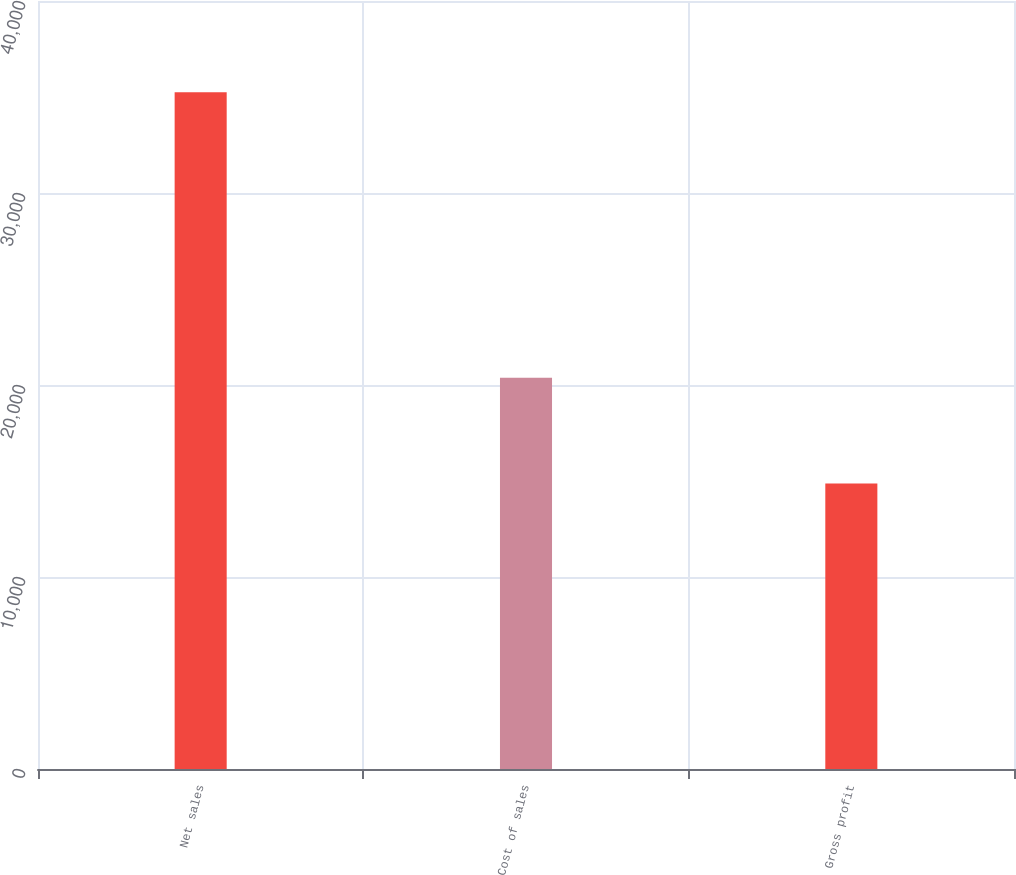Convert chart to OTSL. <chart><loc_0><loc_0><loc_500><loc_500><bar_chart><fcel>Net sales<fcel>Cost of sales<fcel>Gross profit<nl><fcel>35245<fcel>20379<fcel>14866<nl></chart> 